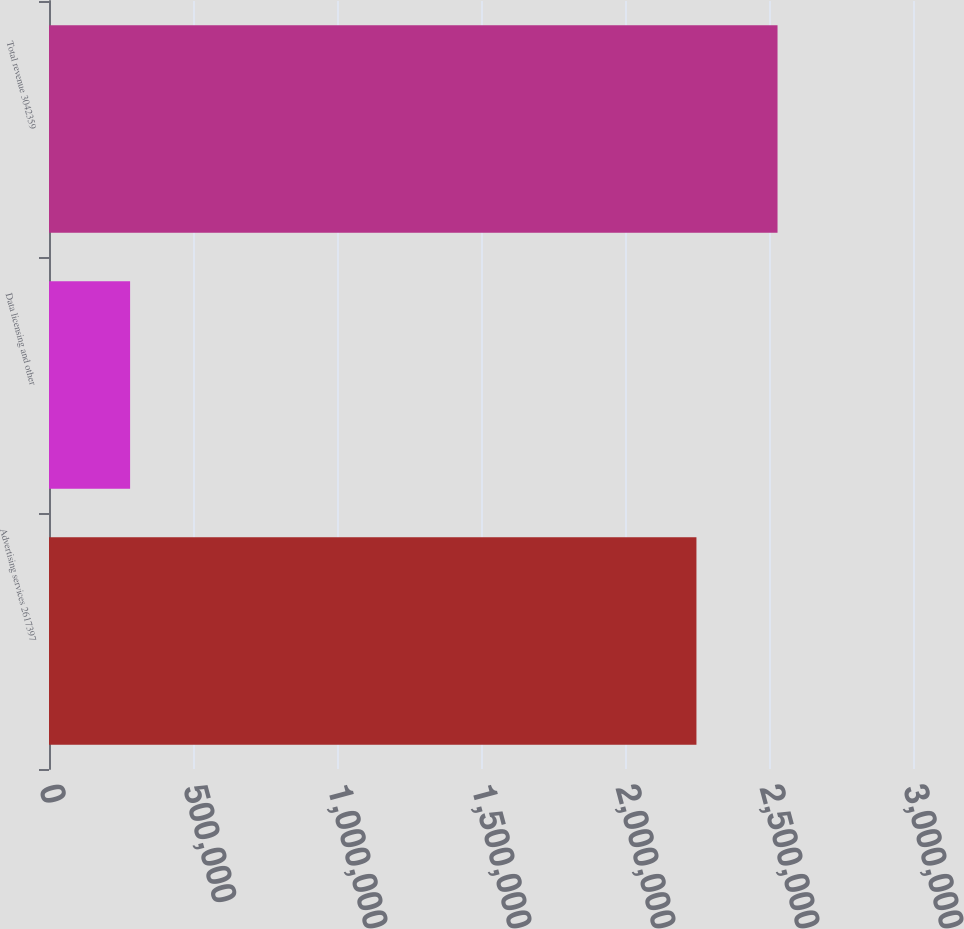Convert chart to OTSL. <chart><loc_0><loc_0><loc_500><loc_500><bar_chart><fcel>Advertising services 2617397<fcel>Data licensing and other<fcel>Total revenue 3042359<nl><fcel>2.24805e+06<fcel>281567<fcel>2.52962e+06<nl></chart> 